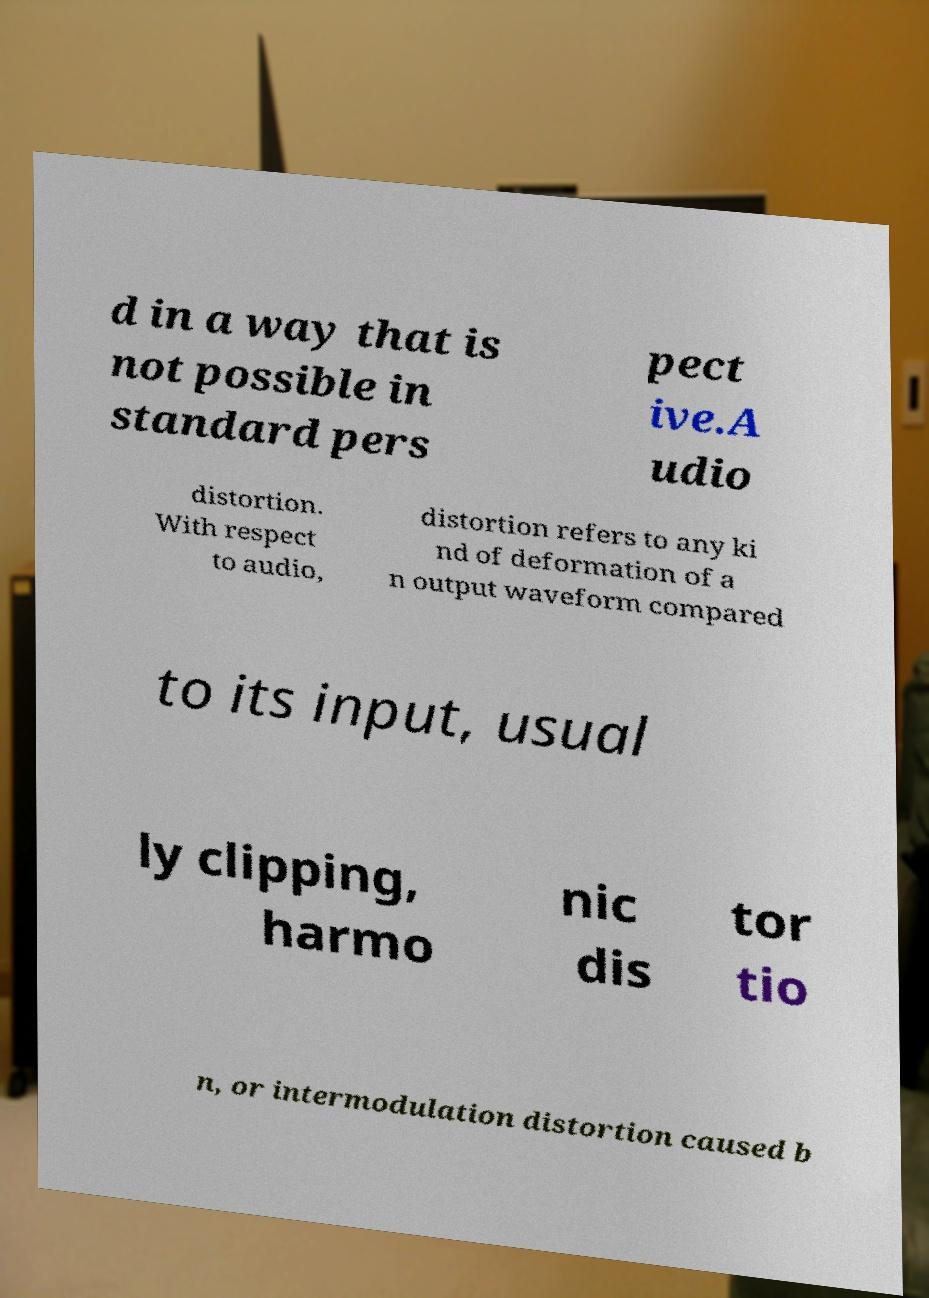I need the written content from this picture converted into text. Can you do that? d in a way that is not possible in standard pers pect ive.A udio distortion. With respect to audio, distortion refers to any ki nd of deformation of a n output waveform compared to its input, usual ly clipping, harmo nic dis tor tio n, or intermodulation distortion caused b 